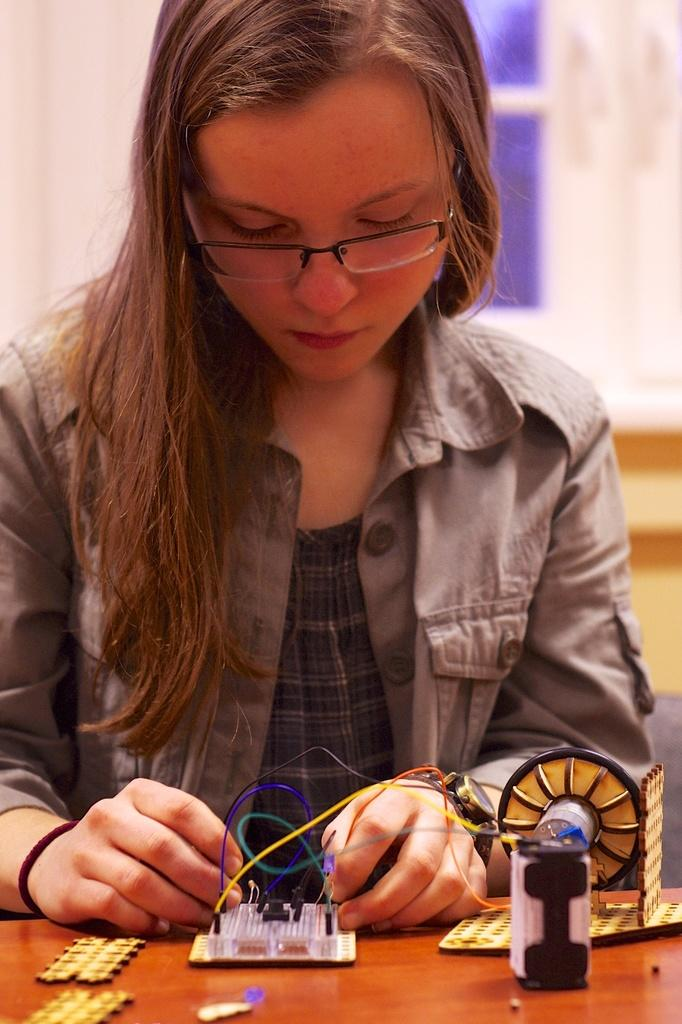What is the woman in the image doing? The woman is sitting in the image. What is the woman holding in the image? The woman is holding wires and cables in the image. What can be seen on the wooden surface in the image? There are electrical objects on a wooden surface in the image. How many chickens are present in the image? There are no chickens present in the image. What hobbies does the woman have, based on the image? The image does not provide information about the woman's hobbies. 